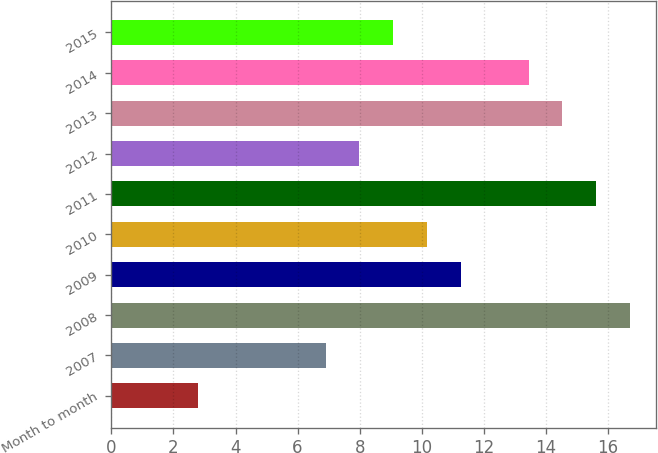Convert chart. <chart><loc_0><loc_0><loc_500><loc_500><bar_chart><fcel>Month to month<fcel>2007<fcel>2008<fcel>2009<fcel>2010<fcel>2011<fcel>2012<fcel>2013<fcel>2014<fcel>2015<nl><fcel>2.8<fcel>6.9<fcel>16.71<fcel>11.26<fcel>10.17<fcel>15.62<fcel>7.99<fcel>14.53<fcel>13.44<fcel>9.08<nl></chart> 